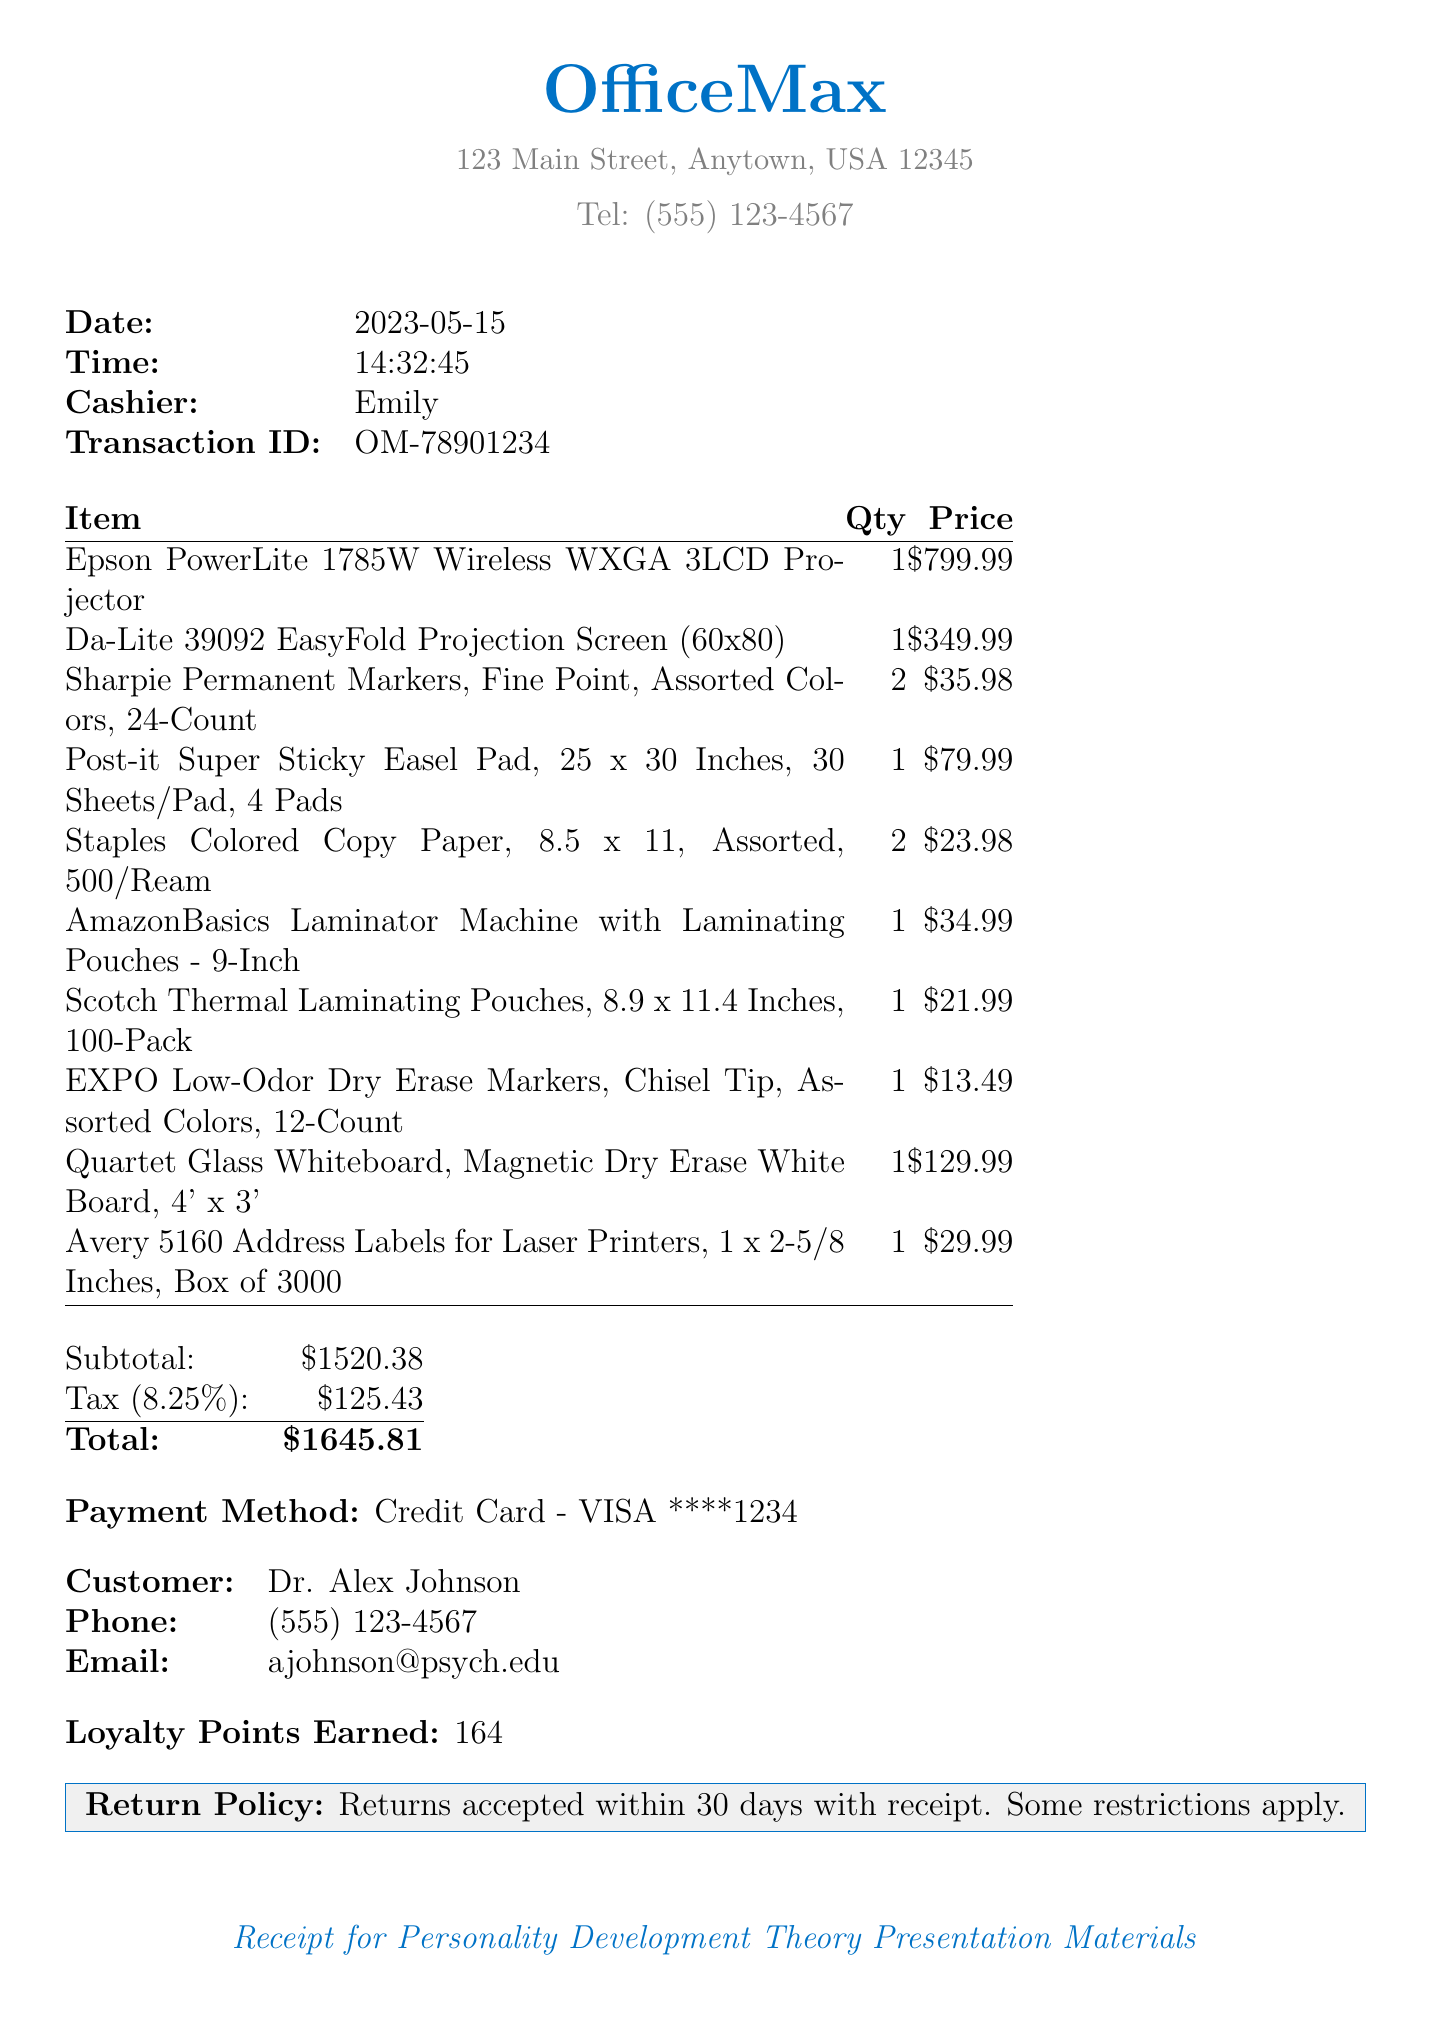What is the date of the transaction? The date of the transaction is located in the document details.
Answer: 2023-05-15 Who was the cashier during the transaction? The cashier's name is provided in the document under cashier details.
Answer: Emily What is the total amount spent? The total amount is given in the summary of the receipt.
Answer: $1645.81 How many loyalty points were earned? The loyalty points earned are listed near the end of the document.
Answer: 164 What is the name of the projector purchased? The name of the projector can be found in the list of items purchased.
Answer: Epson PowerLite 1785W Wireless WXGA 3LCD Projector What is the tax amount applied to the purchase? The tax amount is shown in the financial summary section of the receipt.
Answer: $125.43 What is the return policy stated on the receipt? The return policy is included as a footnote towards the end of the document.
Answer: Returns accepted within 30 days with receipt How many colored copy paper reams were purchased? The quantity of colored copy paper reams is provided in the items list.
Answer: 2 What is the name of the customer? The customer's name is listed in the customer details section of the receipt.
Answer: Dr. Alex Johnson 